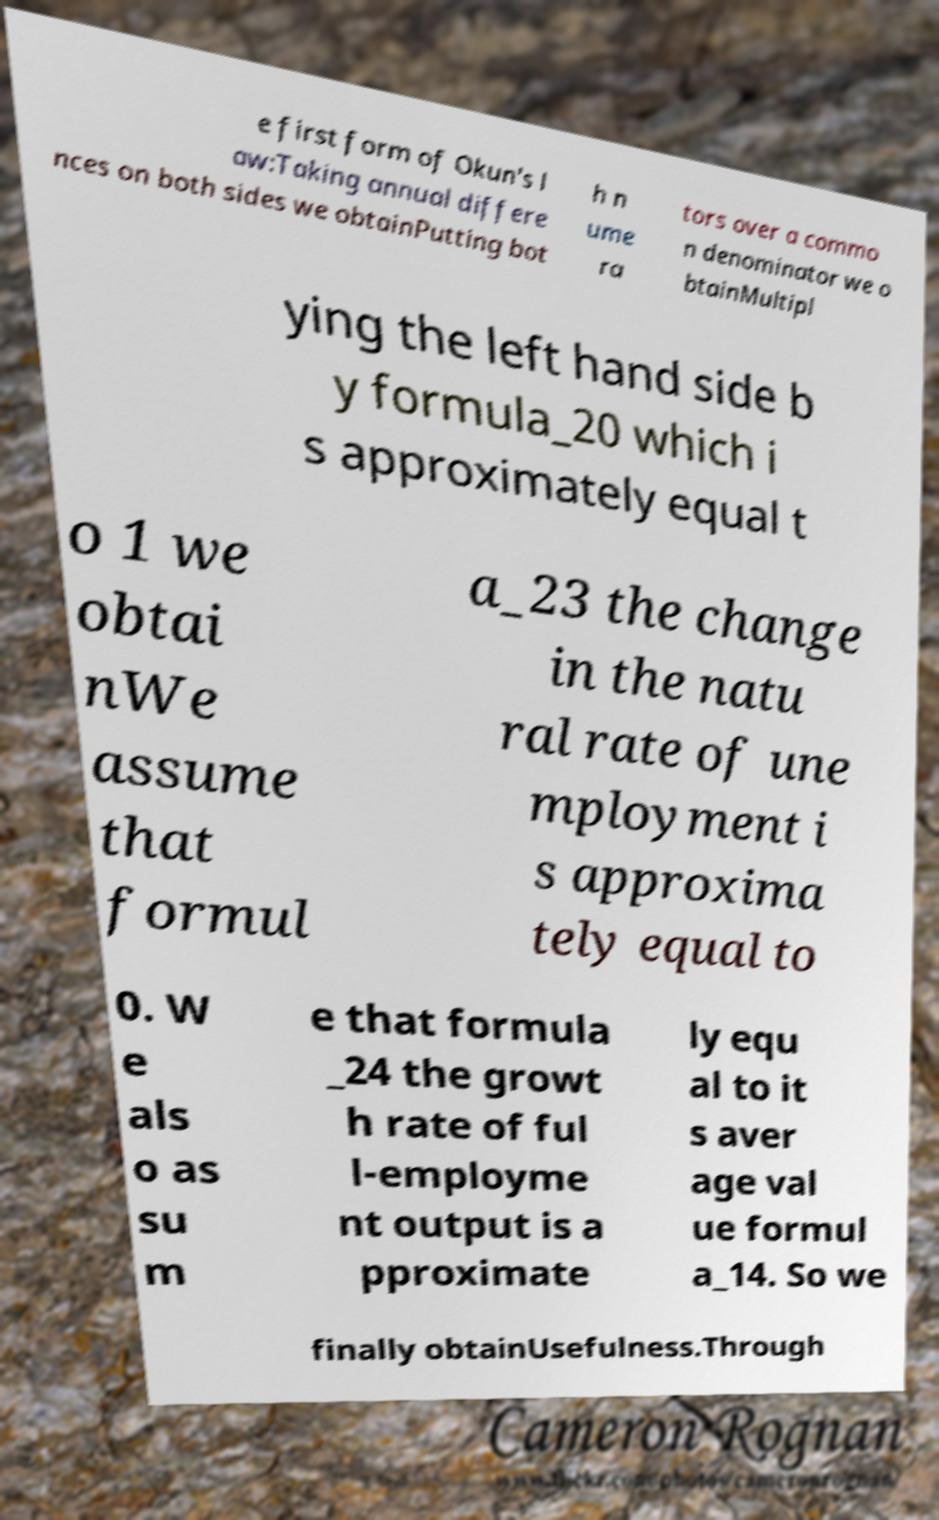Can you read and provide the text displayed in the image?This photo seems to have some interesting text. Can you extract and type it out for me? e first form of Okun's l aw:Taking annual differe nces on both sides we obtainPutting bot h n ume ra tors over a commo n denominator we o btainMultipl ying the left hand side b y formula_20 which i s approximately equal t o 1 we obtai nWe assume that formul a_23 the change in the natu ral rate of une mployment i s approxima tely equal to 0. W e als o as su m e that formula _24 the growt h rate of ful l-employme nt output is a pproximate ly equ al to it s aver age val ue formul a_14. So we finally obtainUsefulness.Through 